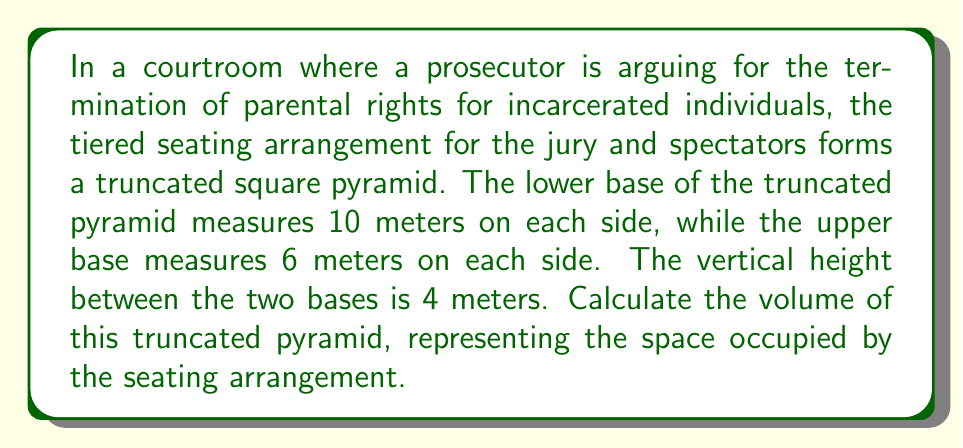Show me your answer to this math problem. To calculate the volume of a truncated square pyramid, we can use the following formula:

$$V = \frac{1}{3}h(a^2 + ab + b^2)$$

Where:
$V$ = volume of the truncated pyramid
$h$ = height of the truncated pyramid
$a$ = side length of the lower base
$b$ = side length of the upper base

Given:
$h = 4$ meters
$a = 10$ meters
$b = 6$ meters

Let's substitute these values into the formula:

$$\begin{align*}
V &= \frac{1}{3} \cdot 4 \cdot (10^2 + 10 \cdot 6 + 6^2) \\[10pt]
&= \frac{4}{3} \cdot (100 + 60 + 36) \\[10pt]
&= \frac{4}{3} \cdot 196 \\[10pt]
&= \frac{784}{3} \\[10pt]
&= 261.33\overline{3}
\end{align*}$$

Therefore, the volume of the truncated pyramid representing the tiered seating arrangement is approximately 261.33 cubic meters.
Answer: $261.33\overline{3}$ cubic meters 